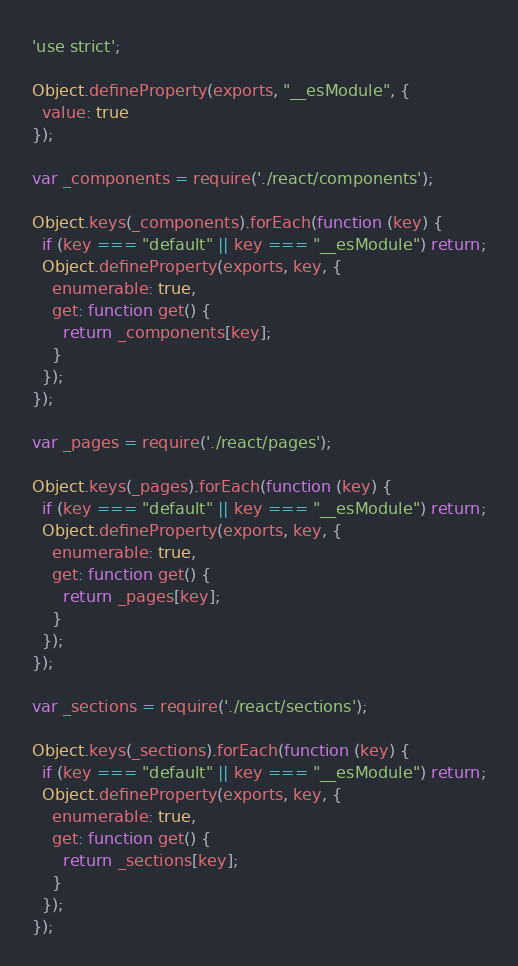Convert code to text. <code><loc_0><loc_0><loc_500><loc_500><_JavaScript_>'use strict';

Object.defineProperty(exports, "__esModule", {
  value: true
});

var _components = require('./react/components');

Object.keys(_components).forEach(function (key) {
  if (key === "default" || key === "__esModule") return;
  Object.defineProperty(exports, key, {
    enumerable: true,
    get: function get() {
      return _components[key];
    }
  });
});

var _pages = require('./react/pages');

Object.keys(_pages).forEach(function (key) {
  if (key === "default" || key === "__esModule") return;
  Object.defineProperty(exports, key, {
    enumerable: true,
    get: function get() {
      return _pages[key];
    }
  });
});

var _sections = require('./react/sections');

Object.keys(_sections).forEach(function (key) {
  if (key === "default" || key === "__esModule") return;
  Object.defineProperty(exports, key, {
    enumerable: true,
    get: function get() {
      return _sections[key];
    }
  });
});</code> 